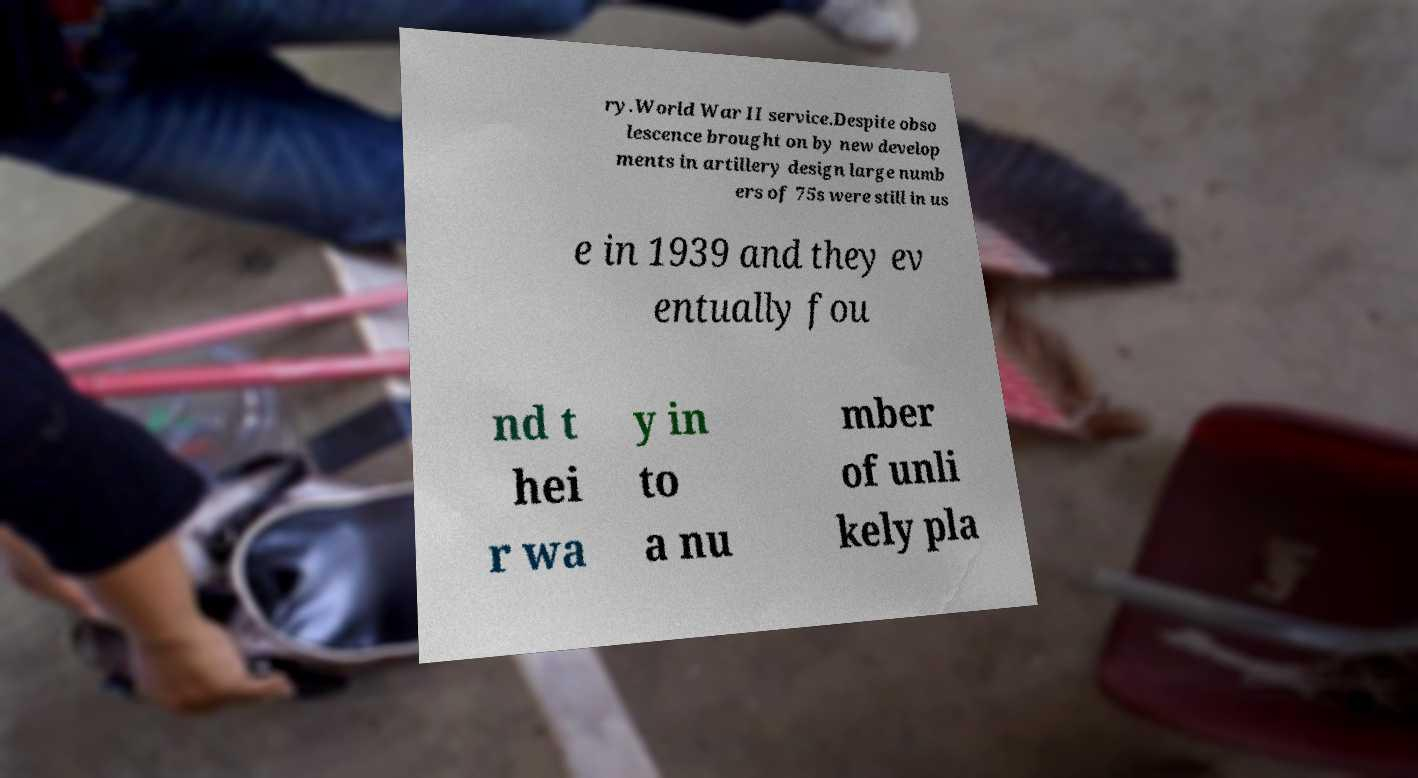Can you read and provide the text displayed in the image?This photo seems to have some interesting text. Can you extract and type it out for me? ry.World War II service.Despite obso lescence brought on by new develop ments in artillery design large numb ers of 75s were still in us e in 1939 and they ev entually fou nd t hei r wa y in to a nu mber of unli kely pla 